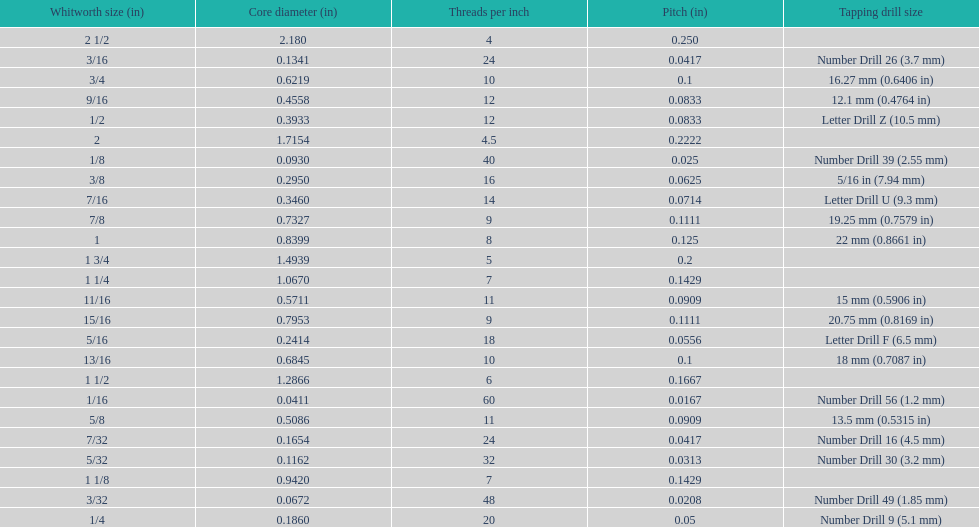What is the core diameter of the last whitworth thread size? 2.180. 